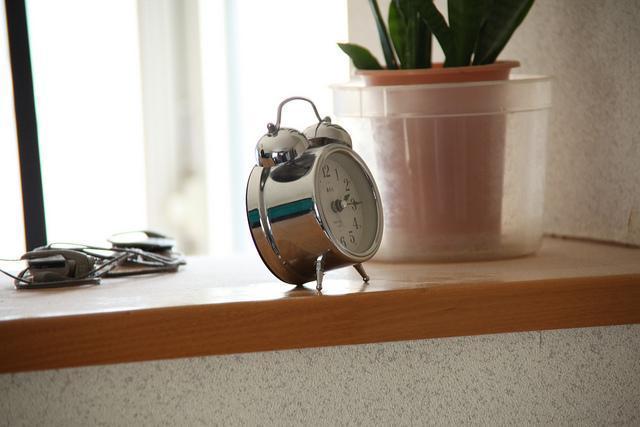How many giraffes are sitting there?
Give a very brief answer. 0. 